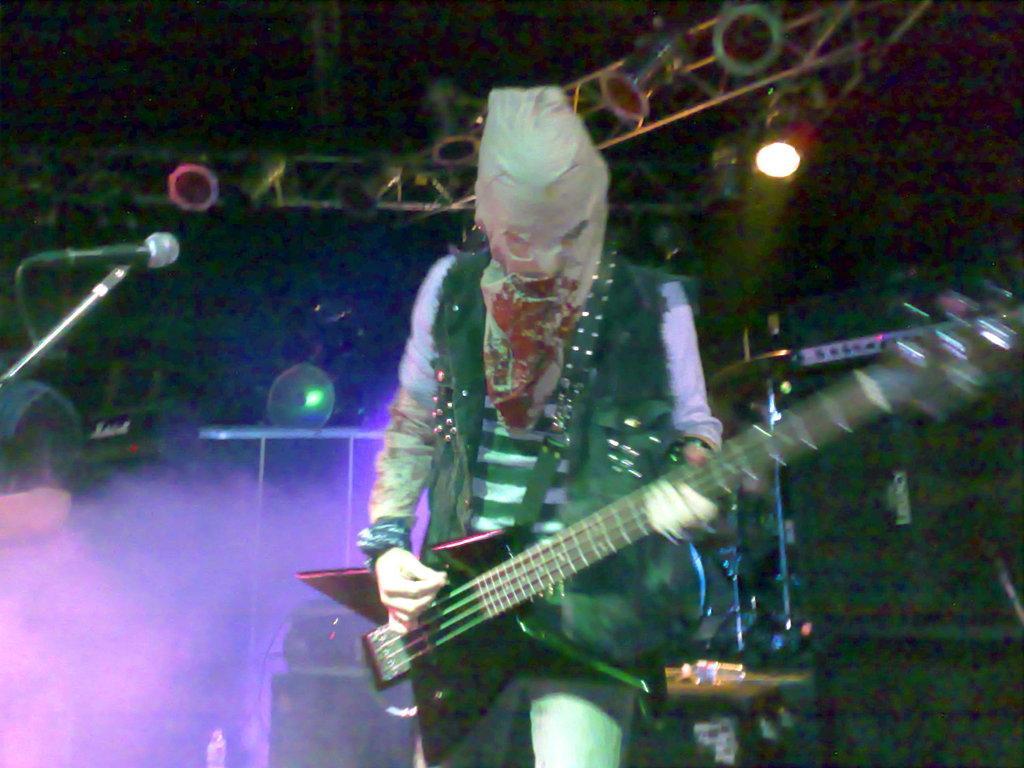How would you summarize this image in a sentence or two? In this picture there is a person in the center of the image, by holding a guitar in his hands and there are spotlights at the top side of the image and there is a speaker on the right side of the image. 